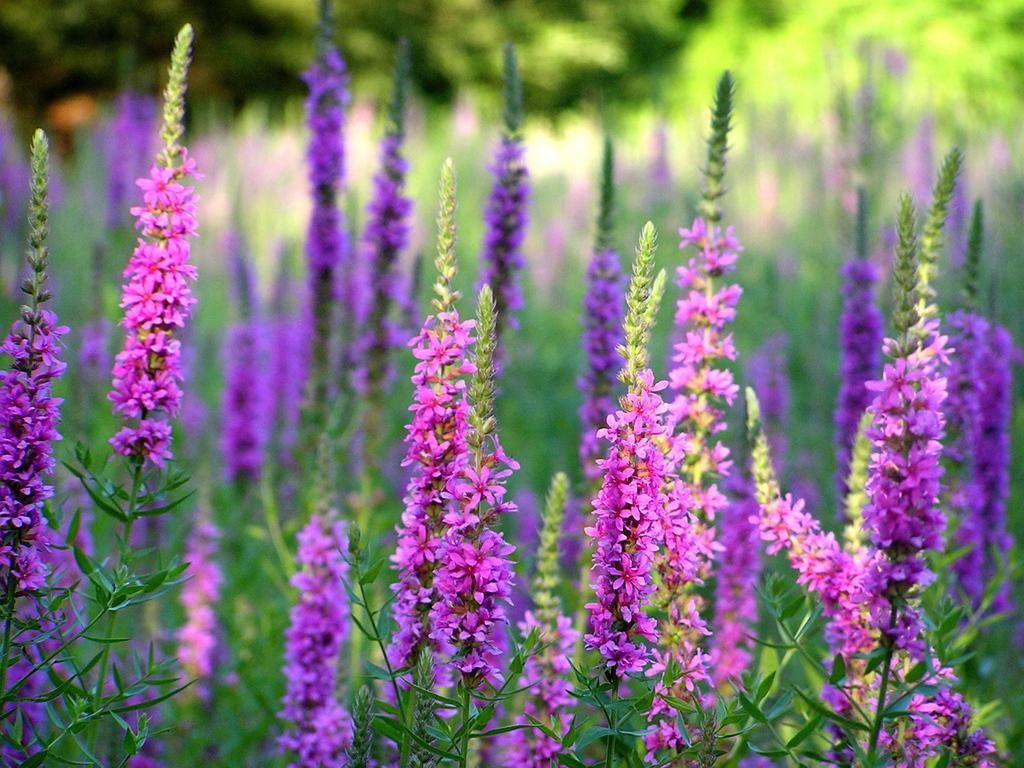What type of plants are present in the image? There are plants with flowers in the image. Can you describe the group of trees in the image? There is a group of trees at the top of the image. What type of fear can be seen in the image? There is no fear present in the image; it features plants with flowers and a group of trees. What type of servant can be seen in the image? There is no servant present in the image; it features plants with flowers and a group of trees. 